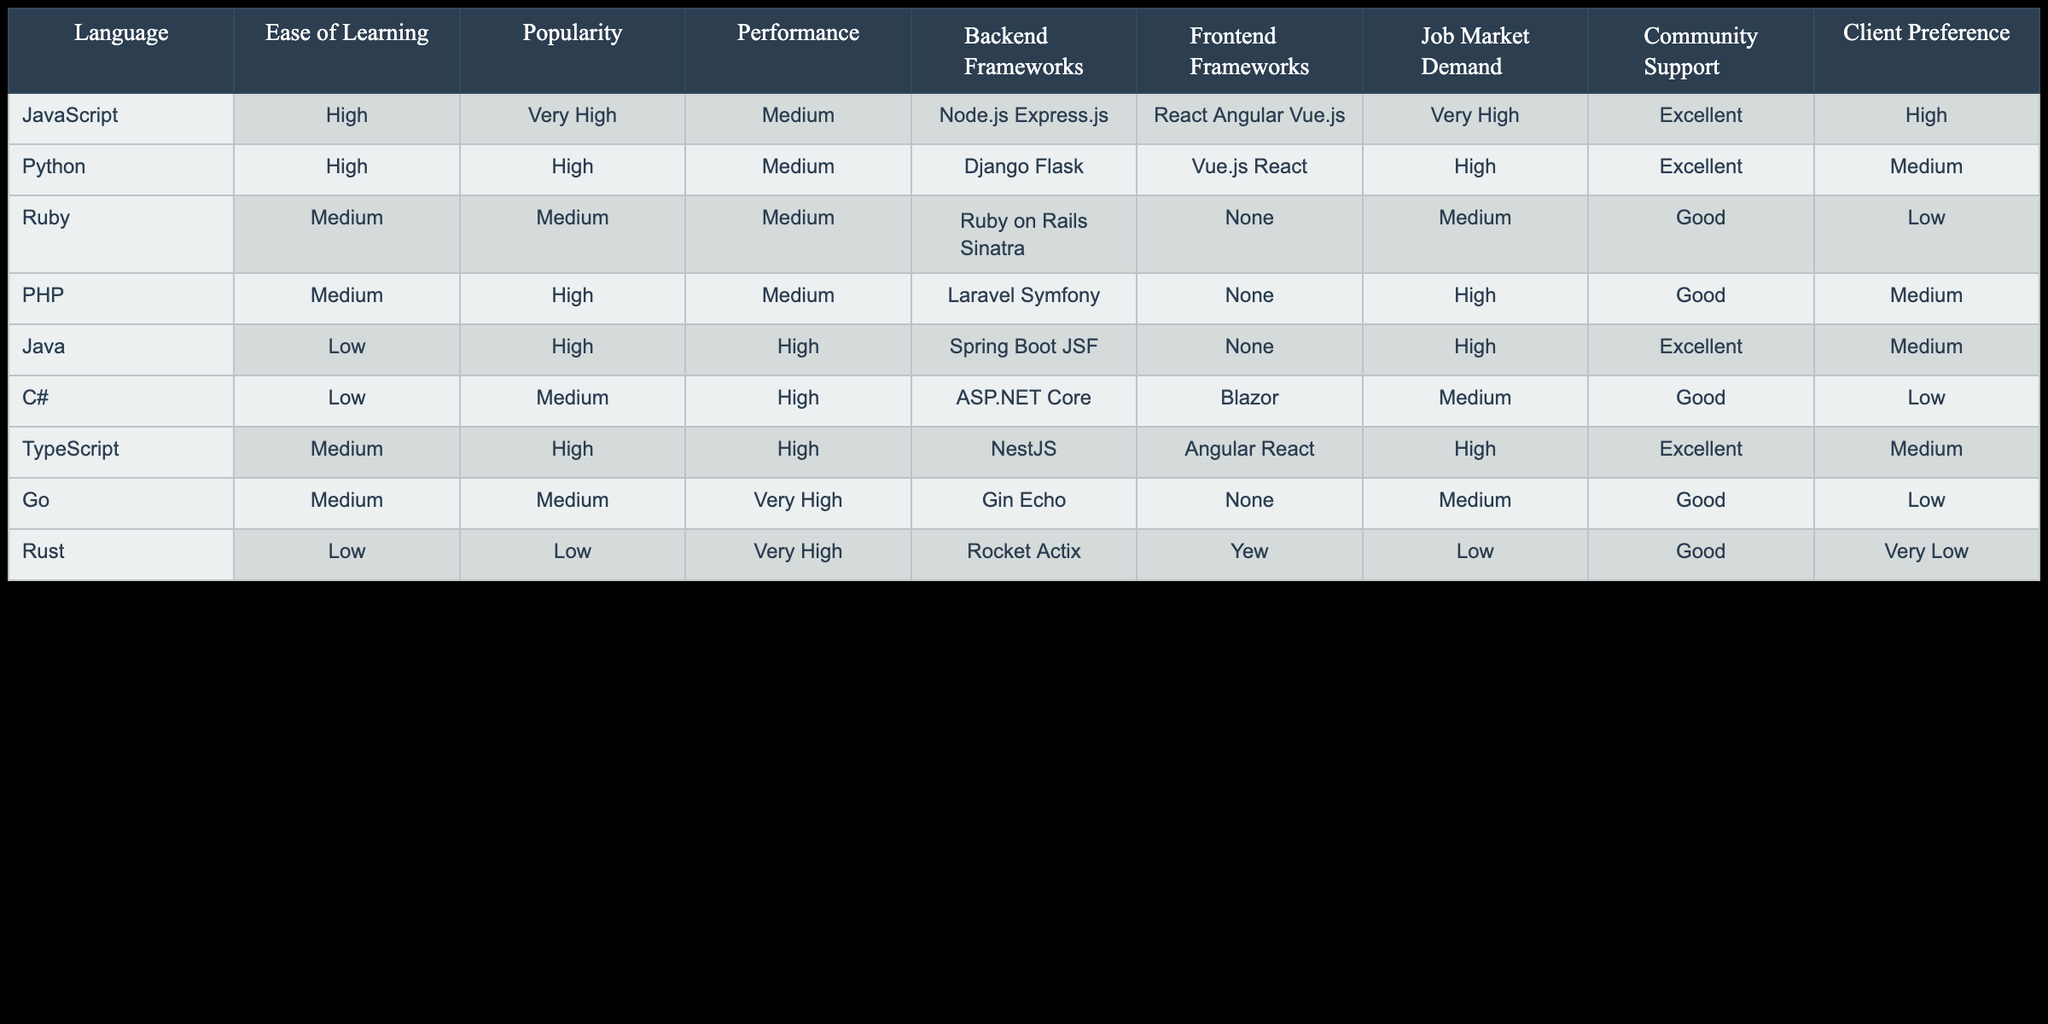What's the most popular programming language for web development? The table shows that JavaScript has the popularity rating of "Very High", which is higher than any other programming language listed.
Answer: JavaScript Which programming language has the worst job market demand? By examining the Job Market Demand column, Rust shows "Low", which is lower than any other programming language in the table.
Answer: Rust True or False: Java has a high performance rating. The Performance column indicates that Java has a "High" performance rating, therefore the statement is true.
Answer: True What is the average ease of learning rating among the programming languages with "High" popularity? The languages with "High" popularity are Python, PHP, TypeScript, and Java. Their ease of learning ratings are "High", "Medium", "Medium", and "Low", respectively. So, the average rating can be calculated as: (3 high + 2 medium + 1 low) / 4 = 1.5 which is "Medium".
Answer: Medium Which programming language is most preferred by clients and has excellent community support? Looking at the Client Preference and Community Support columns, TypeScript has "Medium" client preference but "Excellent" community support, whereas JavaScript has "High" client preference and "Excellent" support. While both have excellent community support, JavaScript ranks higher in client preference.
Answer: JavaScript Which language offers both a high performance rating and has a backend framework? The languages with a "High" performance rating are Java, C#, and Go. Only Java and C# have backend frameworks listed (Spring Boot, ASP.NET Core). Go has a backend framework (Gin) but not a high performance rating. Thus, Java and C# are the correct answers.
Answer: Java, C# Is there a programming language that has a backend framework but none for frontend? Observing the Backend Frameworks and Frontend Frameworks columns, Ruby and Go are both languages that have backend frameworks indicated but show "None" for frontend frameworks.
Answer: Yes What can be inferred about the relationship between community support and job market demand in the table? By comparing these two columns, we can see that languages like JavaScript and Python have excellent community support and also very high job market demand. Meanwhile, Rust shows low community support and also low job market demand, suggesting that better community support may correlate with higher demand in the job market.
Answer: Community support likely impacts job market demand What is the difference in performance ratings between JavaScript and PHP? JavaScript has a performance rating of "Medium" while PHP also has a performance rating of "Medium", resulting in no difference when compared.
Answer: No difference 